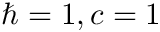<formula> <loc_0><loc_0><loc_500><loc_500>\hbar { = } 1 , c = 1</formula> 